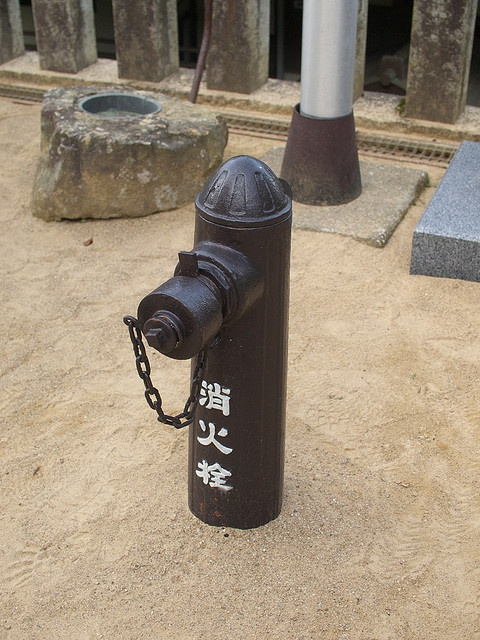Describe the objects in this image and their specific colors. I can see a fire hydrant in black and gray tones in this image. 